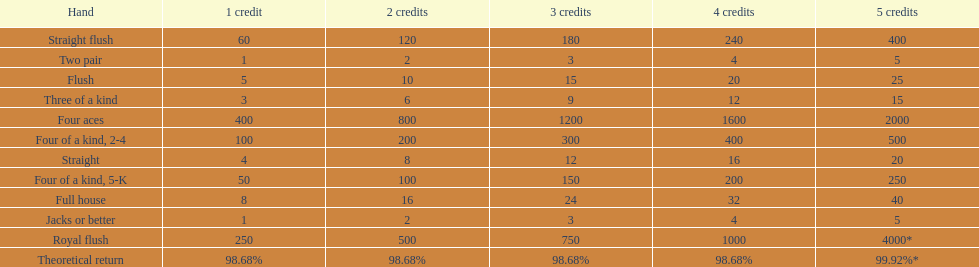What is the difference of payout on 3 credits, between a straight flush and royal flush? 570. 